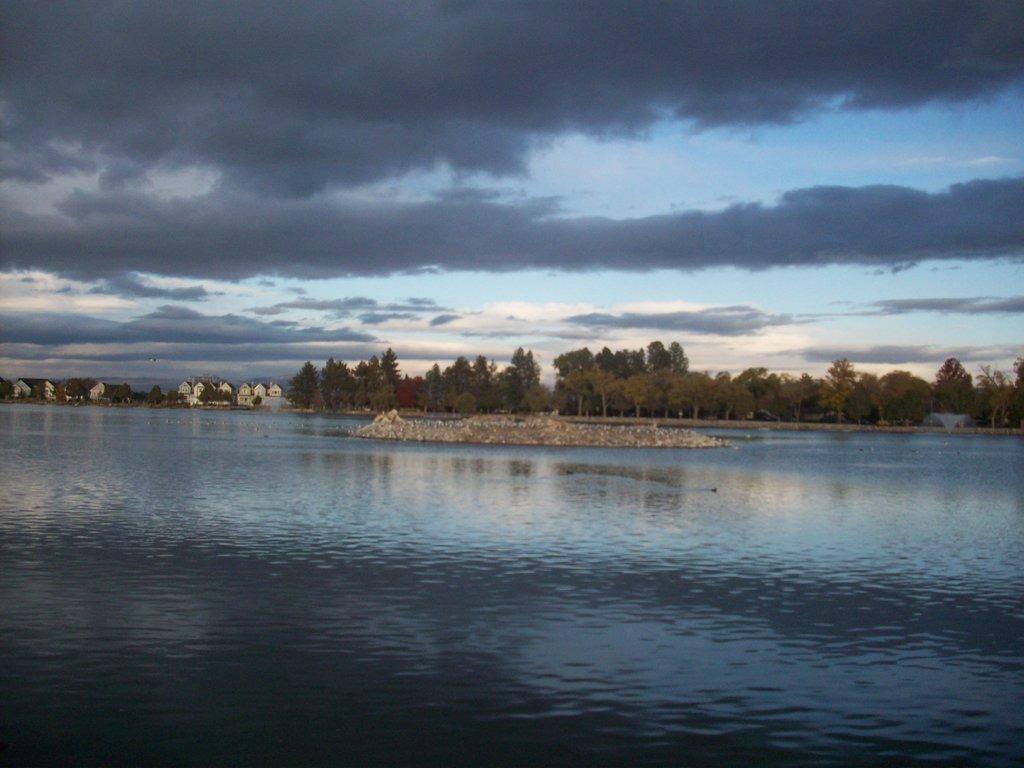Describe this image in one or two sentences. In this image there are some trees in middle of this image and there are some buildings at left side of this image and there is a cloudy sky at top of this image and there is a lake at bottom of this image. 